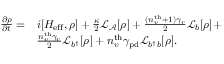<formula> <loc_0><loc_0><loc_500><loc_500>\begin{array} { r l r } { \frac { \partial \rho } { \partial t } = } & { i [ H _ { e f f } , \rho ] + \frac { \kappa } { 2 } \mathcal { L } _ { \mathcal { A } } [ \rho ] + \frac { ( n _ { v } ^ { t h } + 1 ) \gamma _ { r } } { 2 } \mathcal { L } _ { b } [ \rho ] + } & \\ & { \frac { n _ { v } ^ { t h } \gamma _ { r } } { 2 } \mathcal { L } _ { b ^ { \dagger } } [ \rho ] + { n _ { v } ^ { t h } \gamma _ { p d } } \mathcal { L } _ { b ^ { \dagger } b } [ \rho ] . } & \end{array}</formula> 